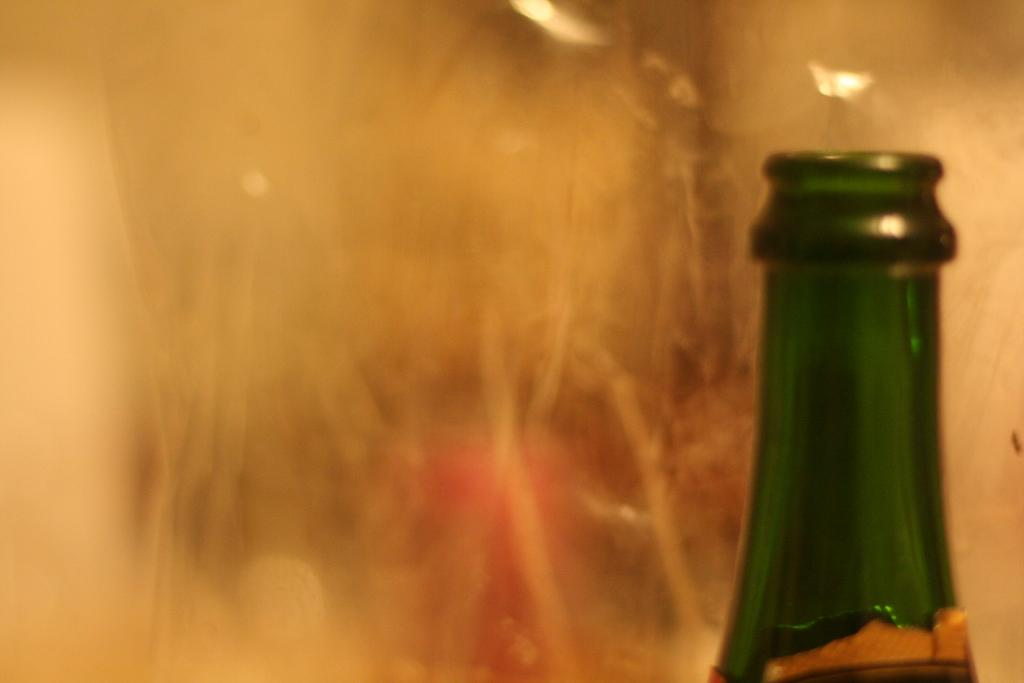What object can be seen in the image? There is a bottle in the image. Can you describe the background of the image? The background of the image is blurry. What type of lipstick can be seen on the wire in the image? There is no lipstick or wire present in the image; it only features a bottle with a blurry background. 